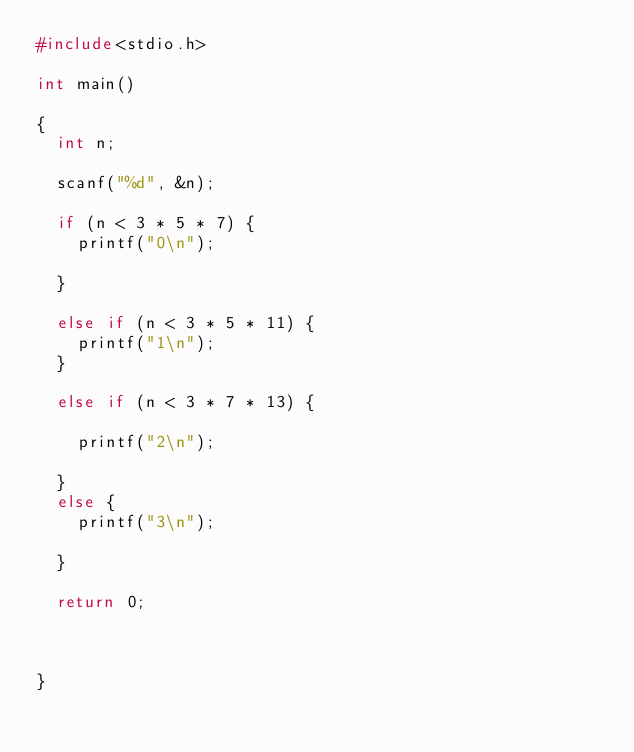<code> <loc_0><loc_0><loc_500><loc_500><_C_>#include<stdio.h>

int main()

{
	int n;

	scanf("%d", &n);

	if (n < 3 * 5 * 7) {
		printf("0\n");

	}
	
	else if (n < 3 * 5 * 11) {
		printf("1\n");
	}
	
	else if (n < 3 * 7 * 13) {

		printf("2\n");

	}
	else {
		printf("3\n");

	}

	return 0;



}</code> 